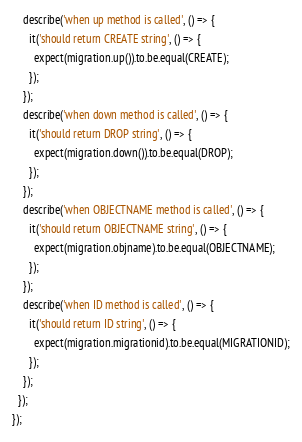<code> <loc_0><loc_0><loc_500><loc_500><_JavaScript_>    describe('when up method is called', () => {
      it('should return CREATE string', () => {
        expect(migration.up()).to.be.equal(CREATE);
      });
    });
    describe('when down method is called', () => {
      it('should return DROP string', () => {
        expect(migration.down()).to.be.equal(DROP);
      });
    });
    describe('when OBJECTNAME method is called', () => {
      it('should return OBJECTNAME string', () => {
        expect(migration.objname).to.be.equal(OBJECTNAME);
      });
    });
    describe('when ID method is called', () => {
      it('should return ID string', () => {
        expect(migration.migrationid).to.be.equal(MIGRATIONID);
      });
    });
  });
});
</code> 